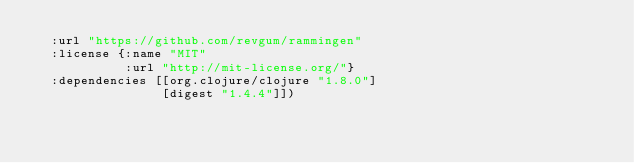<code> <loc_0><loc_0><loc_500><loc_500><_Clojure_>  :url "https://github.com/revgum/rammingen"
  :license {:name "MIT"
            :url "http://mit-license.org/"}
  :dependencies [[org.clojure/clojure "1.8.0"]
                 [digest "1.4.4"]])
</code> 